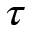Convert formula to latex. <formula><loc_0><loc_0><loc_500><loc_500>\tau</formula> 